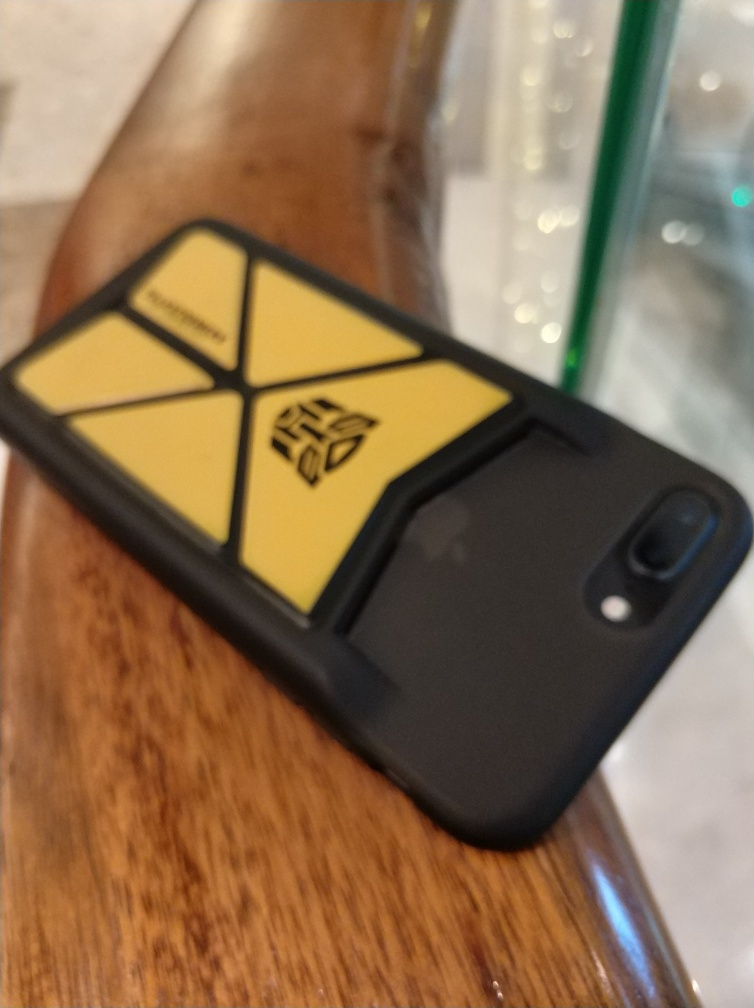What type of setting does this image depict? The image appears to capture a casual indoor setting, likely a café or similar gathering place, emphasized by the wooden surface and drink container in the blurred background. What does the emblem on the phone case represent? The emblem looks like a stylized representation, possibly a brand or a personal symbol of significance to the owner. Its geometric shape and distinctive color make it eye-catching. 